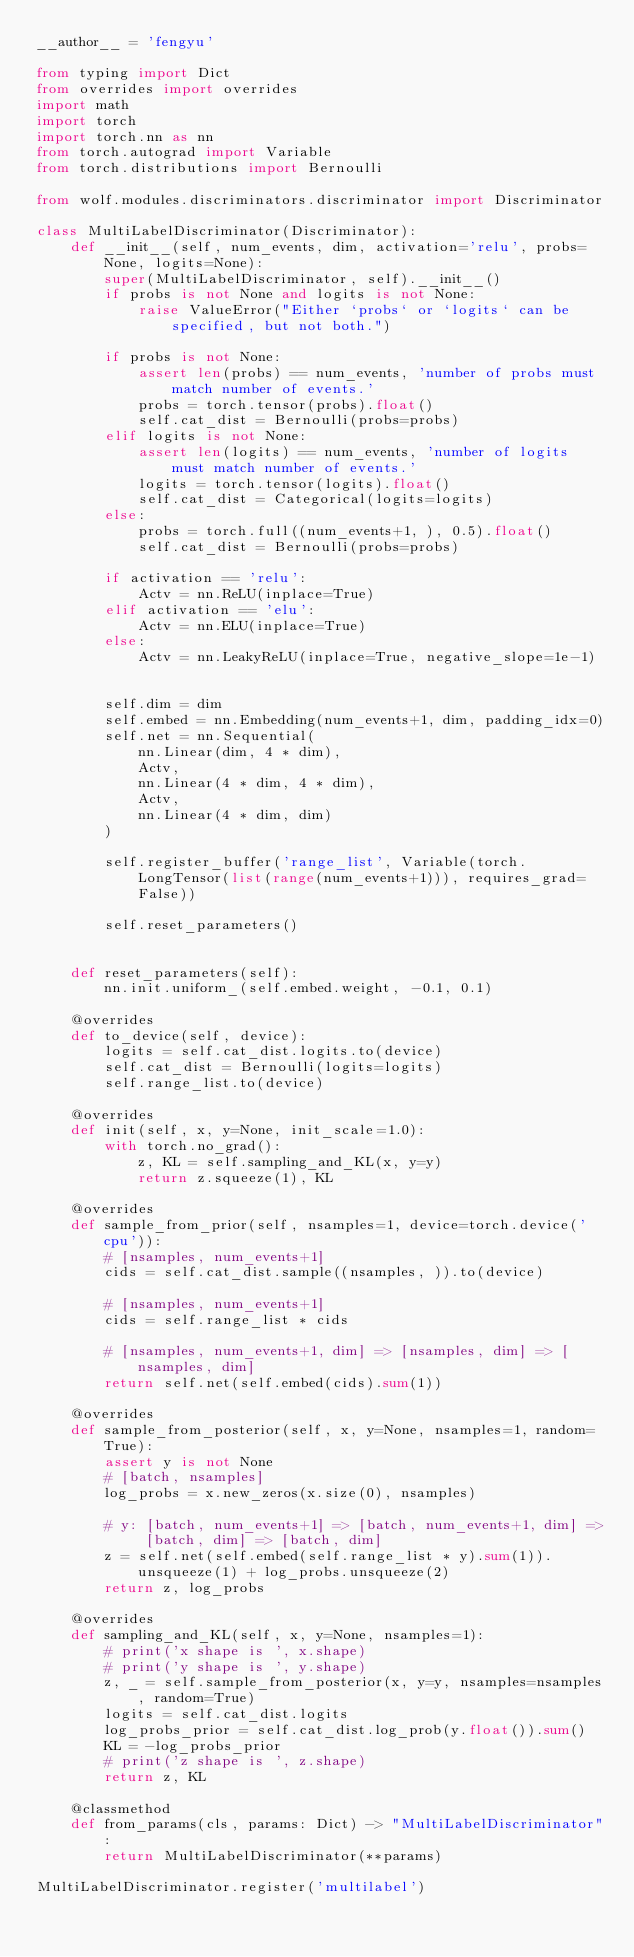Convert code to text. <code><loc_0><loc_0><loc_500><loc_500><_Python_>__author__ = 'fengyu'

from typing import Dict
from overrides import overrides
import math
import torch
import torch.nn as nn
from torch.autograd import Variable
from torch.distributions import Bernoulli

from wolf.modules.discriminators.discriminator import Discriminator

class MultiLabelDiscriminator(Discriminator):
    def __init__(self, num_events, dim, activation='relu', probs=None, logits=None):
        super(MultiLabelDiscriminator, self).__init__()
        if probs is not None and logits is not None:
            raise ValueError("Either `probs` or `logits` can be specified, but not both.")
        
        if probs is not None:
            assert len(probs) == num_events, 'number of probs must match number of events.'
            probs = torch.tensor(probs).float()
            self.cat_dist = Bernoulli(probs=probs)
        elif logits is not None:
            assert len(logits) == num_events, 'number of logits must match number of events.'
            logits = torch.tensor(logits).float()
            self.cat_dist = Categorical(logits=logits)
        else:
            probs = torch.full((num_events+1, ), 0.5).float()
            self.cat_dist = Bernoulli(probs=probs)

        if activation == 'relu':
            Actv = nn.ReLU(inplace=True)
        elif activation == 'elu':
            Actv = nn.ELU(inplace=True)
        else:
            Actv = nn.LeakyReLU(inplace=True, negative_slope=1e-1)
        

        self.dim = dim
        self.embed = nn.Embedding(num_events+1, dim, padding_idx=0)
        self.net = nn.Sequential(
            nn.Linear(dim, 4 * dim),
            Actv,
            nn.Linear(4 * dim, 4 * dim),
            Actv,
            nn.Linear(4 * dim, dim)
        )

        self.register_buffer('range_list', Variable(torch.LongTensor(list(range(num_events+1))), requires_grad=False))

        self.reset_parameters()

    
    def reset_parameters(self):
        nn.init.uniform_(self.embed.weight, -0.1, 0.1)

    @overrides
    def to_device(self, device):
        logits = self.cat_dist.logits.to(device)
        self.cat_dist = Bernoulli(logits=logits)
        self.range_list.to(device)

    @overrides
    def init(self, x, y=None, init_scale=1.0):
        with torch.no_grad():
            z, KL = self.sampling_and_KL(x, y=y)
            return z.squeeze(1), KL

    @overrides
    def sample_from_prior(self, nsamples=1, device=torch.device('cpu')):
        # [nsamples, num_events+1]
        cids = self.cat_dist.sample((nsamples, )).to(device)
        
        # [nsamples, num_events+1]
        cids = self.range_list * cids

        # [nsamples, num_events+1, dim] => [nsamples, dim] => [nsamples, dim]
        return self.net(self.embed(cids).sum(1))
        
    @overrides
    def sample_from_posterior(self, x, y=None, nsamples=1, random=True):
        assert y is not None
        # [batch, nsamples]
        log_probs = x.new_zeros(x.size(0), nsamples)

        # y: [batch, num_events+1] => [batch, num_events+1, dim] => [batch, dim] => [batch, dim]
        z = self.net(self.embed(self.range_list * y).sum(1)).unsqueeze(1) + log_probs.unsqueeze(2)
        return z, log_probs
    
    @overrides
    def sampling_and_KL(self, x, y=None, nsamples=1):
        # print('x shape is ', x.shape)
        # print('y shape is ', y.shape)
        z, _ = self.sample_from_posterior(x, y=y, nsamples=nsamples, random=True)
        logits = self.cat_dist.logits
        log_probs_prior = self.cat_dist.log_prob(y.float()).sum()
        KL = -log_probs_prior
        # print('z shape is ', z.shape)
        return z, KL
    
    @classmethod
    def from_params(cls, params: Dict) -> "MultiLabelDiscriminator":
        return MultiLabelDiscriminator(**params)
    
MultiLabelDiscriminator.register('multilabel')
        </code> 